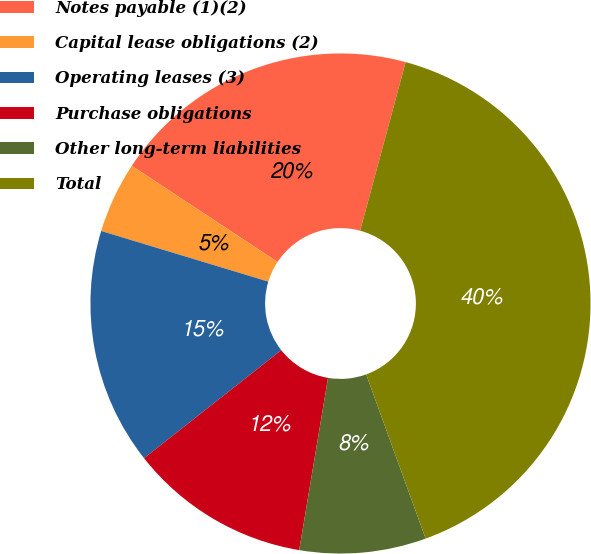<chart> <loc_0><loc_0><loc_500><loc_500><pie_chart><fcel>Notes payable (1)(2)<fcel>Capital lease obligations (2)<fcel>Operating leases (3)<fcel>Purchase obligations<fcel>Other long-term liabilities<fcel>Total<nl><fcel>19.91%<fcel>4.6%<fcel>15.3%<fcel>11.74%<fcel>8.17%<fcel>40.27%<nl></chart> 